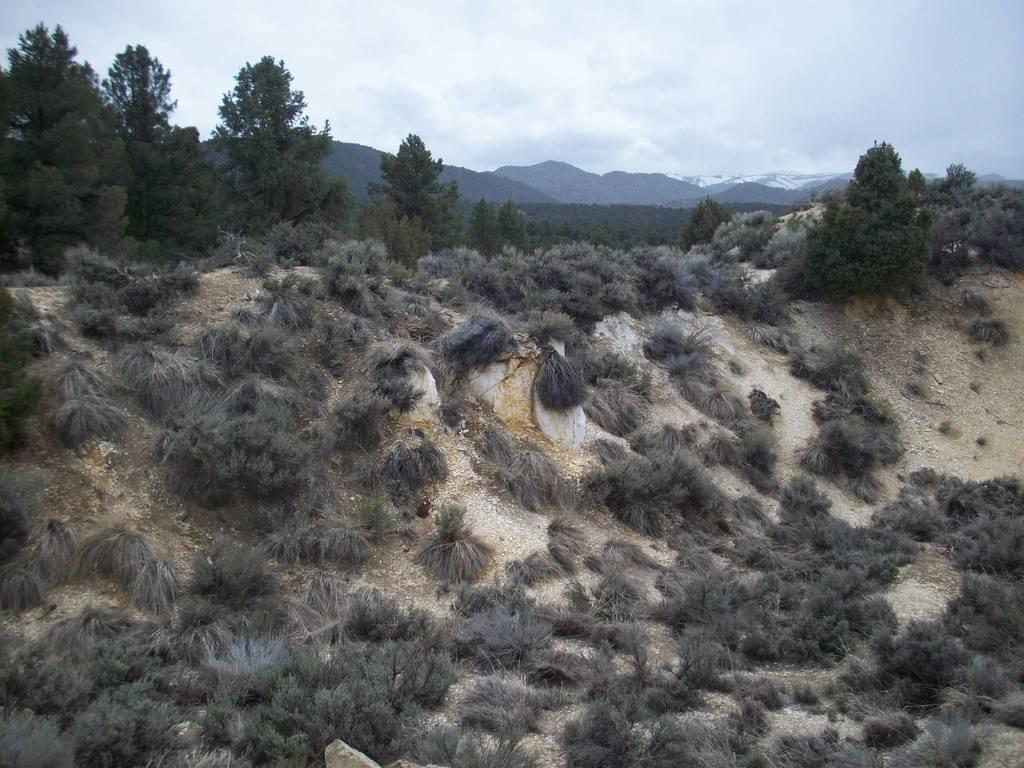What can be seen in the foreground of the picture? There are shrubs and soil in the foreground of the picture. What is visible in the background of the picture? There are trees and hills in the background of the picture. What is the condition of the sky in the image? The sky is cloudy in the image. What type of crime is being committed in the image? There is no indication of any crime being committed in the image. Can you tell me the name of the aunt who is present in the image? There is no person, let alone an aunt, present in the image. 